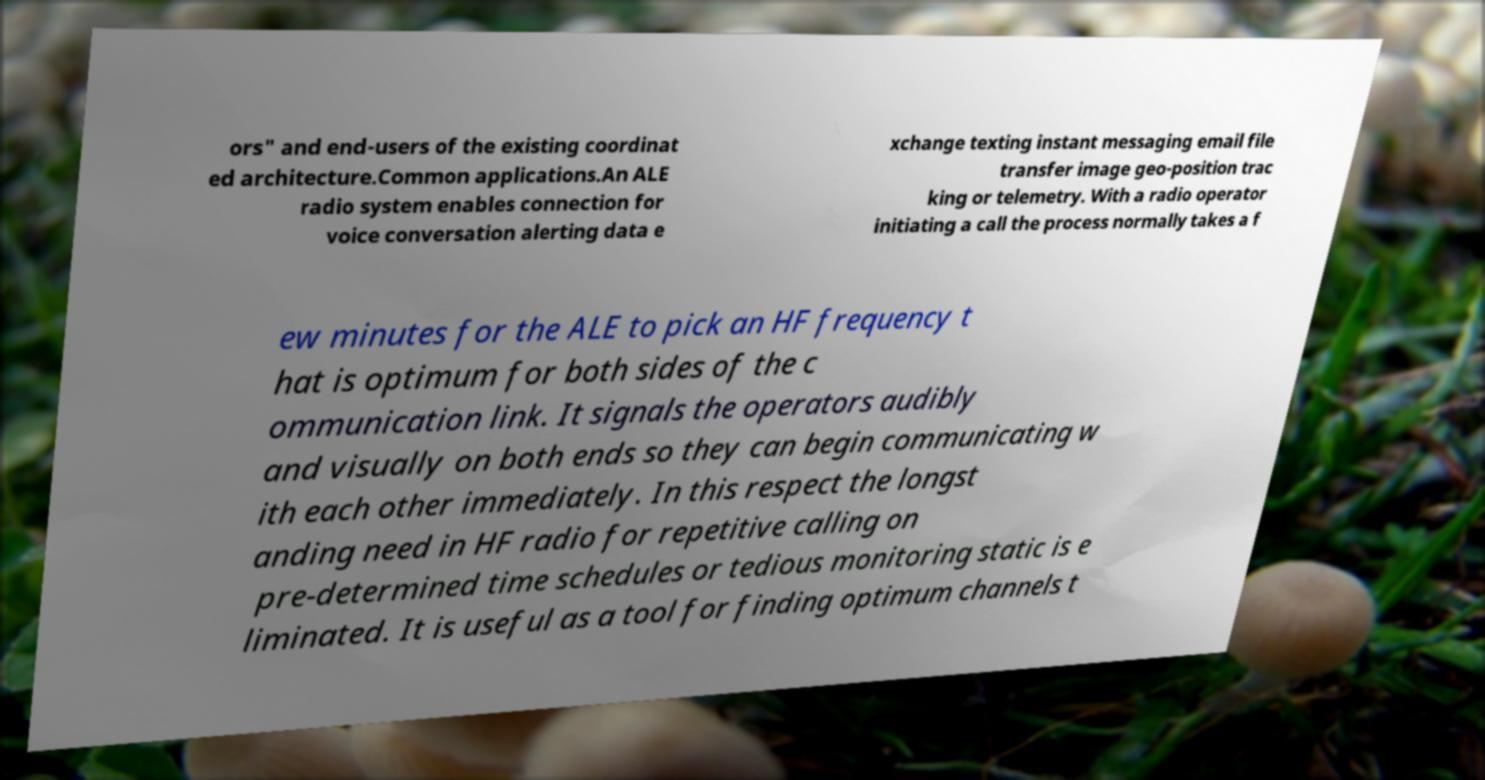For documentation purposes, I need the text within this image transcribed. Could you provide that? ors" and end-users of the existing coordinat ed architecture.Common applications.An ALE radio system enables connection for voice conversation alerting data e xchange texting instant messaging email file transfer image geo-position trac king or telemetry. With a radio operator initiating a call the process normally takes a f ew minutes for the ALE to pick an HF frequency t hat is optimum for both sides of the c ommunication link. It signals the operators audibly and visually on both ends so they can begin communicating w ith each other immediately. In this respect the longst anding need in HF radio for repetitive calling on pre-determined time schedules or tedious monitoring static is e liminated. It is useful as a tool for finding optimum channels t 